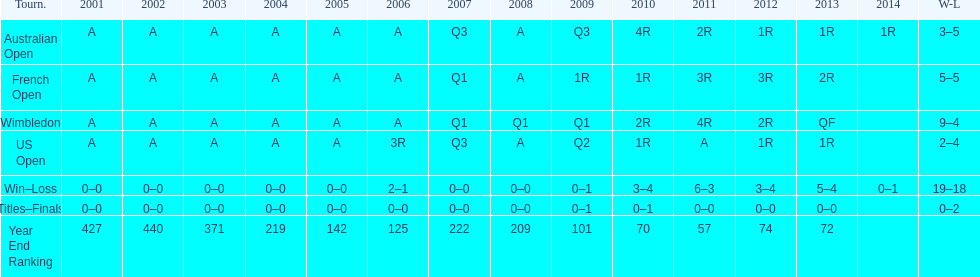What was the total number of matches played from 2001 to 2014? 37. 